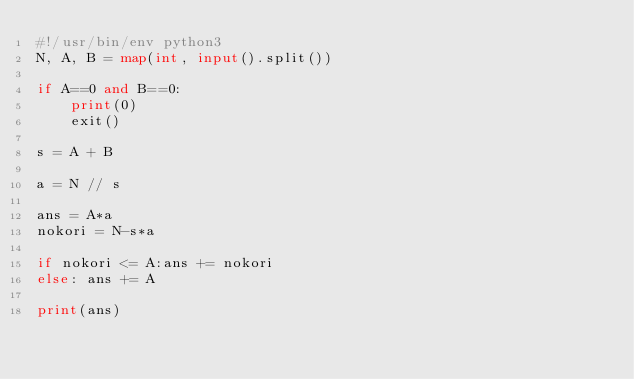<code> <loc_0><loc_0><loc_500><loc_500><_Python_>#!/usr/bin/env python3
N, A, B = map(int, input().split())

if A==0 and B==0:
    print(0)
    exit()

s = A + B

a = N // s

ans = A*a
nokori = N-s*a

if nokori <= A:ans += nokori
else: ans += A

print(ans)
</code> 